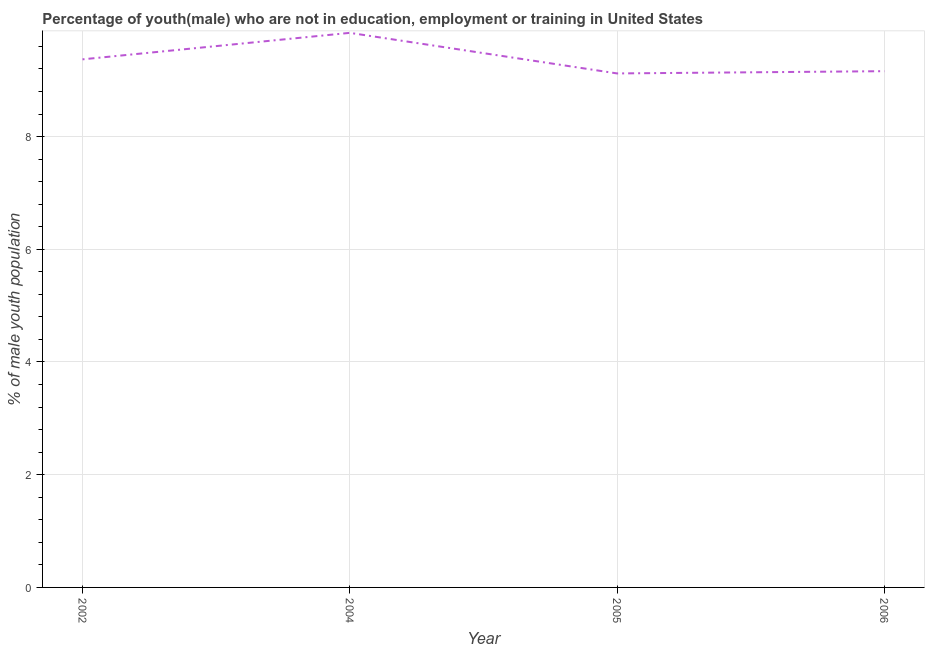What is the unemployed male youth population in 2002?
Ensure brevity in your answer.  9.37. Across all years, what is the maximum unemployed male youth population?
Your answer should be compact. 9.84. Across all years, what is the minimum unemployed male youth population?
Ensure brevity in your answer.  9.12. In which year was the unemployed male youth population minimum?
Your answer should be very brief. 2005. What is the sum of the unemployed male youth population?
Provide a short and direct response. 37.49. What is the average unemployed male youth population per year?
Offer a terse response. 9.37. What is the median unemployed male youth population?
Offer a terse response. 9.26. In how many years, is the unemployed male youth population greater than 5.2 %?
Make the answer very short. 4. Do a majority of the years between 2006 and 2004 (inclusive) have unemployed male youth population greater than 6.4 %?
Make the answer very short. No. What is the ratio of the unemployed male youth population in 2002 to that in 2005?
Keep it short and to the point. 1.03. Is the difference between the unemployed male youth population in 2002 and 2005 greater than the difference between any two years?
Offer a very short reply. No. What is the difference between the highest and the second highest unemployed male youth population?
Make the answer very short. 0.47. What is the difference between the highest and the lowest unemployed male youth population?
Your response must be concise. 0.72. In how many years, is the unemployed male youth population greater than the average unemployed male youth population taken over all years?
Make the answer very short. 1. Does the unemployed male youth population monotonically increase over the years?
Ensure brevity in your answer.  No. How many lines are there?
Keep it short and to the point. 1. Does the graph contain grids?
Your response must be concise. Yes. What is the title of the graph?
Offer a very short reply. Percentage of youth(male) who are not in education, employment or training in United States. What is the label or title of the X-axis?
Offer a terse response. Year. What is the label or title of the Y-axis?
Ensure brevity in your answer.  % of male youth population. What is the % of male youth population of 2002?
Ensure brevity in your answer.  9.37. What is the % of male youth population of 2004?
Provide a succinct answer. 9.84. What is the % of male youth population in 2005?
Provide a short and direct response. 9.12. What is the % of male youth population in 2006?
Your answer should be very brief. 9.16. What is the difference between the % of male youth population in 2002 and 2004?
Provide a short and direct response. -0.47. What is the difference between the % of male youth population in 2002 and 2005?
Your answer should be very brief. 0.25. What is the difference between the % of male youth population in 2002 and 2006?
Your response must be concise. 0.21. What is the difference between the % of male youth population in 2004 and 2005?
Provide a succinct answer. 0.72. What is the difference between the % of male youth population in 2004 and 2006?
Give a very brief answer. 0.68. What is the difference between the % of male youth population in 2005 and 2006?
Provide a short and direct response. -0.04. What is the ratio of the % of male youth population in 2002 to that in 2004?
Provide a short and direct response. 0.95. What is the ratio of the % of male youth population in 2002 to that in 2005?
Provide a succinct answer. 1.03. What is the ratio of the % of male youth population in 2002 to that in 2006?
Your answer should be very brief. 1.02. What is the ratio of the % of male youth population in 2004 to that in 2005?
Keep it short and to the point. 1.08. What is the ratio of the % of male youth population in 2004 to that in 2006?
Ensure brevity in your answer.  1.07. What is the ratio of the % of male youth population in 2005 to that in 2006?
Provide a short and direct response. 1. 